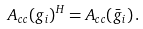Convert formula to latex. <formula><loc_0><loc_0><loc_500><loc_500>A _ { c c } ( g _ { i } ) ^ { H } = A _ { c c } ( \bar { g } _ { i } ) \, .</formula> 